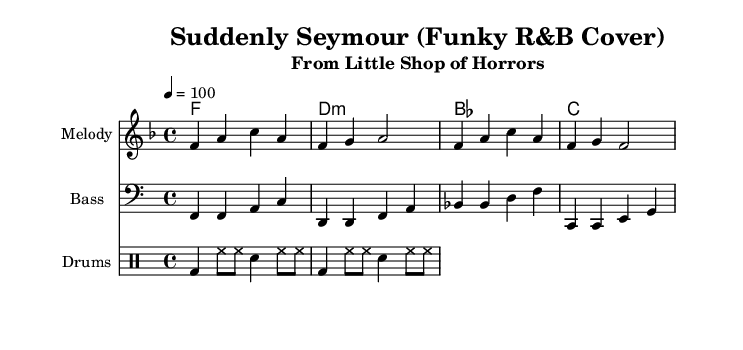What is the key signature of this music? The key signature indicated is F major, which has one flat (B flat). This is shown in the beginning of the sheet music.
Answer: F major What is the time signature of this music? The time signature is 4/4, which means there are four beats in each measure. This is clearly marked at the beginning of the sheet music.
Answer: 4/4 What is the tempo marking for the piece? The tempo marking is indicated as 4 = 100, which means there are 100 beats per minute. This is noted in the header section of the sheet music.
Answer: 100 How many different instruments are represented in the score? The score includes three different staves: one for the melody, one for the bass, and one for drums, indicating three instruments.
Answer: Three instruments What type of chords are primarily used in the harmonies section? The chords include major and minor chords, such as F major, D minor, B flat major, and C major. This is derived from analyzing the names of the chords listed in the harmonies section.
Answer: Major and minor What is the rhythm pattern for the drums? The drum pattern consists of bass drum (bd), hi-hat (hh), and snare (sn) notes in a consistent repetitive sequence. This is seen in the drummode section where the specific notes are laid out.
Answer: Bass, hi-hat, snare What musical genre does this cover reflect? It reflects the Rhythm and Blues genre, as indicated in the title and style of the arrangement. It emphasizes a funky style, characteristic of R&B music.
Answer: Rhythm and Blues 